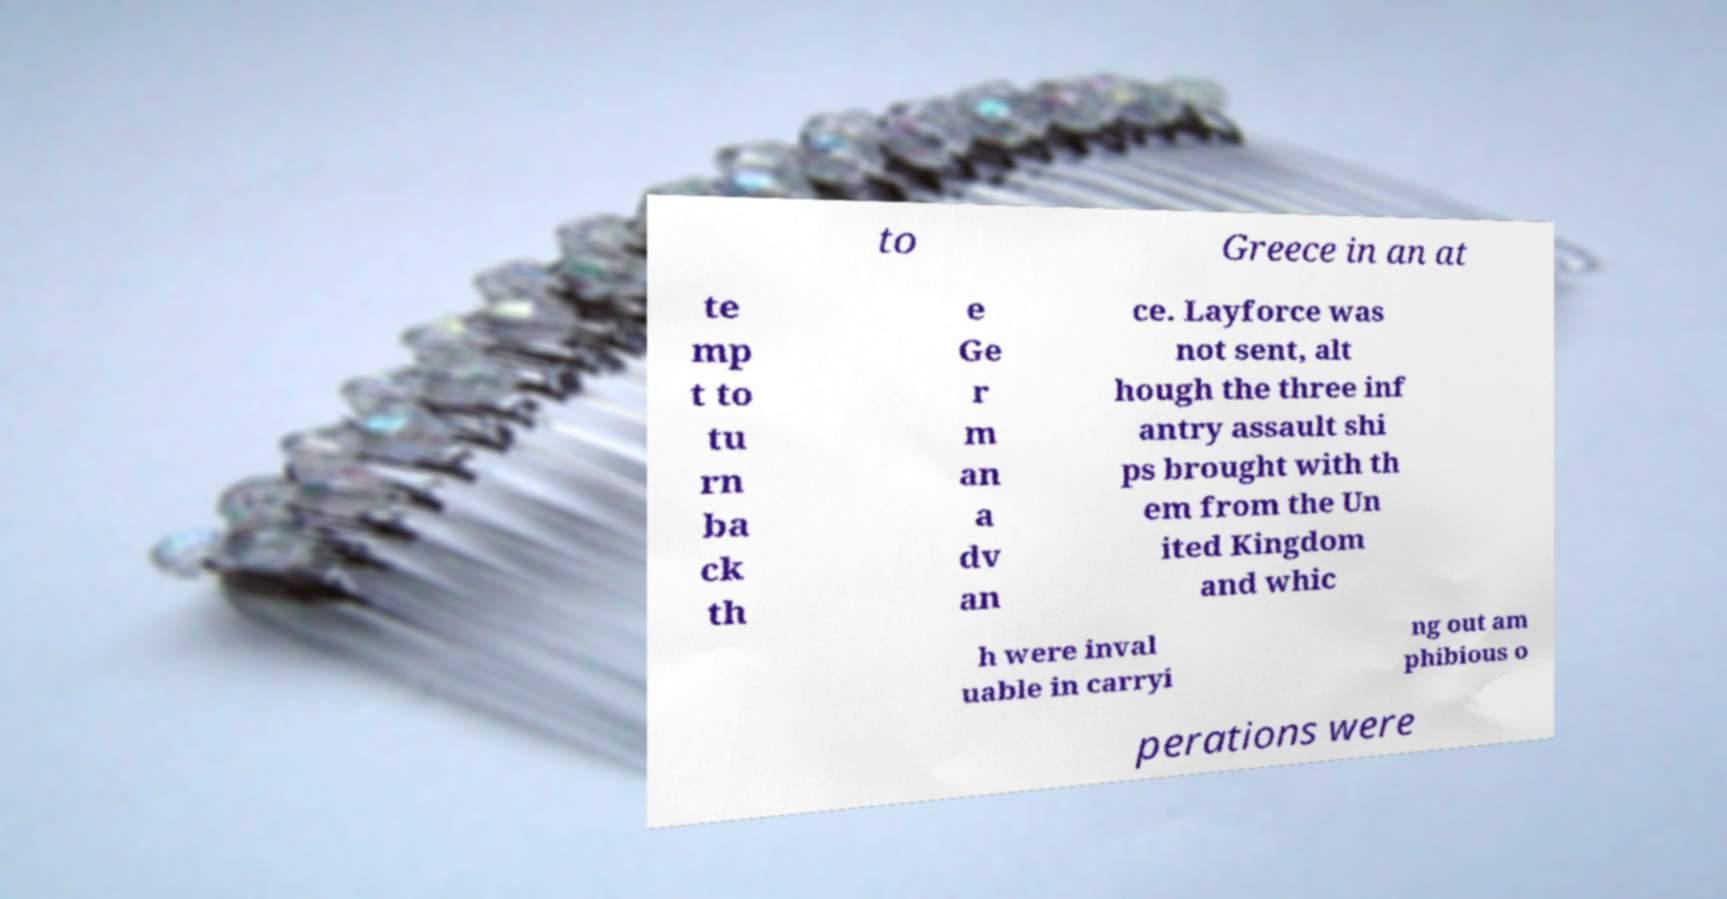Can you accurately transcribe the text from the provided image for me? to Greece in an at te mp t to tu rn ba ck th e Ge r m an a dv an ce. Layforce was not sent, alt hough the three inf antry assault shi ps brought with th em from the Un ited Kingdom and whic h were inval uable in carryi ng out am phibious o perations were 